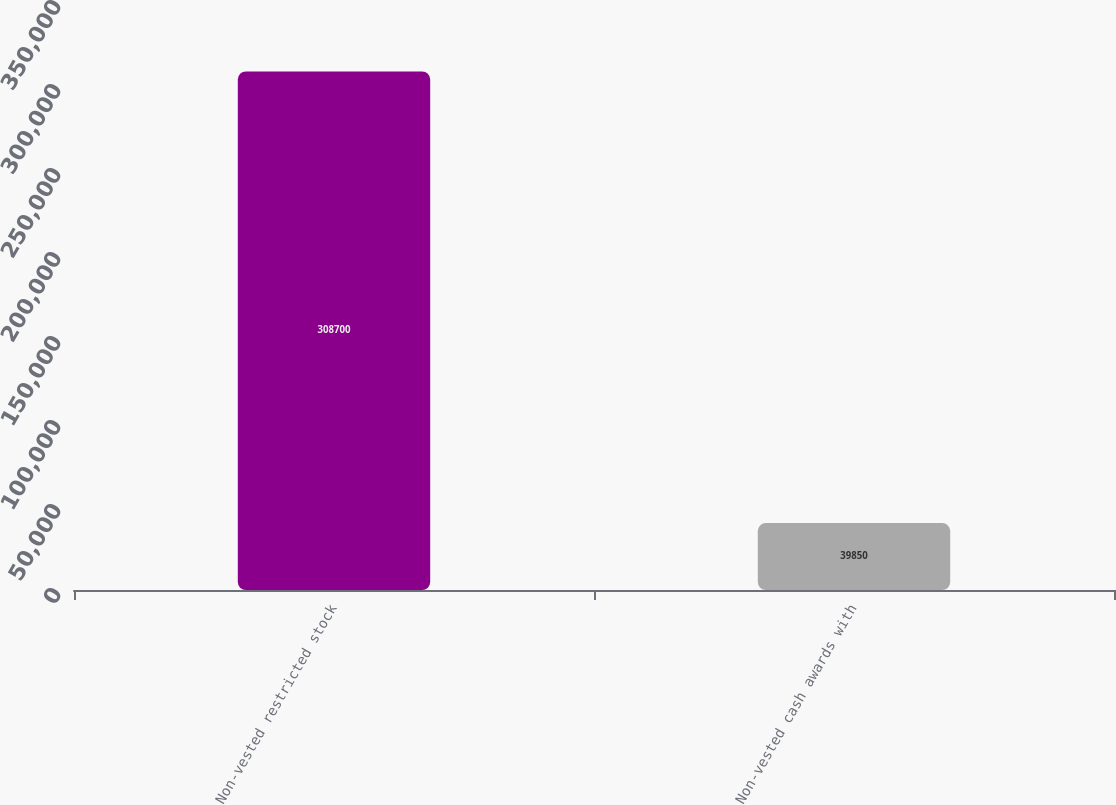Convert chart to OTSL. <chart><loc_0><loc_0><loc_500><loc_500><bar_chart><fcel>Non-vested restricted stock<fcel>Non-vested cash awards with<nl><fcel>308700<fcel>39850<nl></chart> 